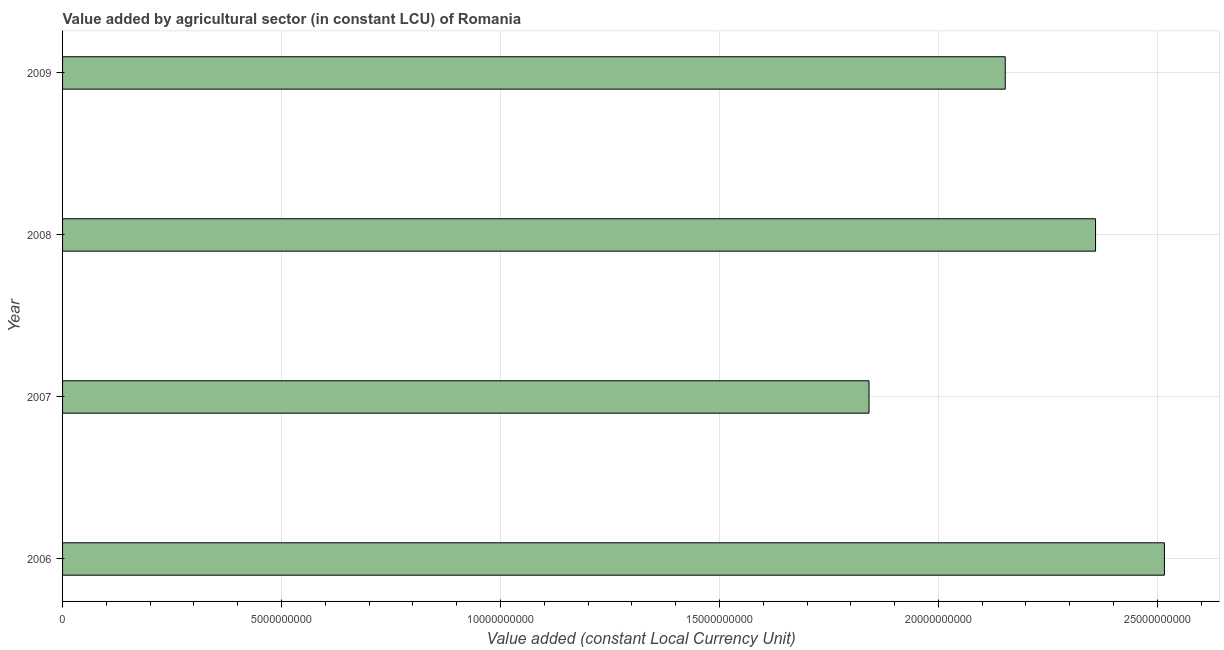What is the title of the graph?
Your answer should be compact. Value added by agricultural sector (in constant LCU) of Romania. What is the label or title of the X-axis?
Provide a short and direct response. Value added (constant Local Currency Unit). What is the label or title of the Y-axis?
Offer a terse response. Year. What is the value added by agriculture sector in 2009?
Give a very brief answer. 2.15e+1. Across all years, what is the maximum value added by agriculture sector?
Your response must be concise. 2.52e+1. Across all years, what is the minimum value added by agriculture sector?
Offer a terse response. 1.84e+1. In which year was the value added by agriculture sector maximum?
Make the answer very short. 2006. What is the sum of the value added by agriculture sector?
Provide a short and direct response. 8.87e+1. What is the difference between the value added by agriculture sector in 2007 and 2009?
Your response must be concise. -3.11e+09. What is the average value added by agriculture sector per year?
Ensure brevity in your answer.  2.22e+1. What is the median value added by agriculture sector?
Give a very brief answer. 2.26e+1. Do a majority of the years between 2008 and 2009 (inclusive) have value added by agriculture sector greater than 4000000000 LCU?
Provide a succinct answer. Yes. What is the ratio of the value added by agriculture sector in 2006 to that in 2008?
Make the answer very short. 1.07. What is the difference between the highest and the second highest value added by agriculture sector?
Give a very brief answer. 1.57e+09. Is the sum of the value added by agriculture sector in 2008 and 2009 greater than the maximum value added by agriculture sector across all years?
Your answer should be compact. Yes. What is the difference between the highest and the lowest value added by agriculture sector?
Keep it short and to the point. 6.75e+09. In how many years, is the value added by agriculture sector greater than the average value added by agriculture sector taken over all years?
Offer a very short reply. 2. How many bars are there?
Your answer should be very brief. 4. Are all the bars in the graph horizontal?
Your response must be concise. Yes. Are the values on the major ticks of X-axis written in scientific E-notation?
Offer a terse response. No. What is the Value added (constant Local Currency Unit) in 2006?
Offer a very short reply. 2.52e+1. What is the Value added (constant Local Currency Unit) in 2007?
Offer a terse response. 1.84e+1. What is the Value added (constant Local Currency Unit) in 2008?
Your answer should be very brief. 2.36e+1. What is the Value added (constant Local Currency Unit) of 2009?
Give a very brief answer. 2.15e+1. What is the difference between the Value added (constant Local Currency Unit) in 2006 and 2007?
Offer a very short reply. 6.75e+09. What is the difference between the Value added (constant Local Currency Unit) in 2006 and 2008?
Your answer should be compact. 1.57e+09. What is the difference between the Value added (constant Local Currency Unit) in 2006 and 2009?
Provide a succinct answer. 3.63e+09. What is the difference between the Value added (constant Local Currency Unit) in 2007 and 2008?
Your response must be concise. -5.17e+09. What is the difference between the Value added (constant Local Currency Unit) in 2007 and 2009?
Provide a short and direct response. -3.11e+09. What is the difference between the Value added (constant Local Currency Unit) in 2008 and 2009?
Offer a terse response. 2.06e+09. What is the ratio of the Value added (constant Local Currency Unit) in 2006 to that in 2007?
Offer a terse response. 1.37. What is the ratio of the Value added (constant Local Currency Unit) in 2006 to that in 2008?
Make the answer very short. 1.07. What is the ratio of the Value added (constant Local Currency Unit) in 2006 to that in 2009?
Your answer should be compact. 1.17. What is the ratio of the Value added (constant Local Currency Unit) in 2007 to that in 2008?
Offer a terse response. 0.78. What is the ratio of the Value added (constant Local Currency Unit) in 2007 to that in 2009?
Give a very brief answer. 0.86. What is the ratio of the Value added (constant Local Currency Unit) in 2008 to that in 2009?
Offer a very short reply. 1.1. 